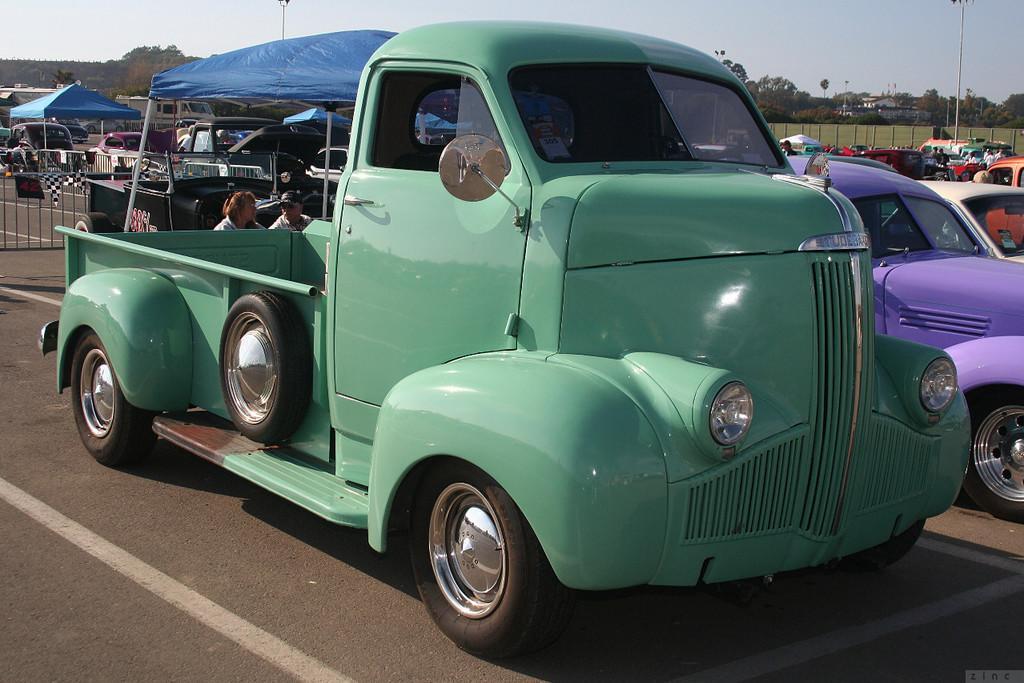Could you give a brief overview of what you see in this image? In this image we can see many vehicles. There is a sky in the image. There are few tents in the image. There is a grassy land in the image. There are few people in the image. There are street pole and barrier in the image. 